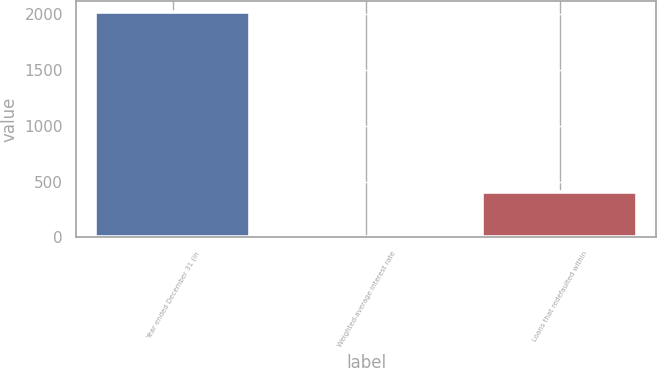Convert chart to OTSL. <chart><loc_0><loc_0><loc_500><loc_500><bar_chart><fcel>Year ended December 31 (in<fcel>Weighted-average interest rate<fcel>Loans that redefaulted within<nl><fcel>2016<fcel>4.76<fcel>407<nl></chart> 